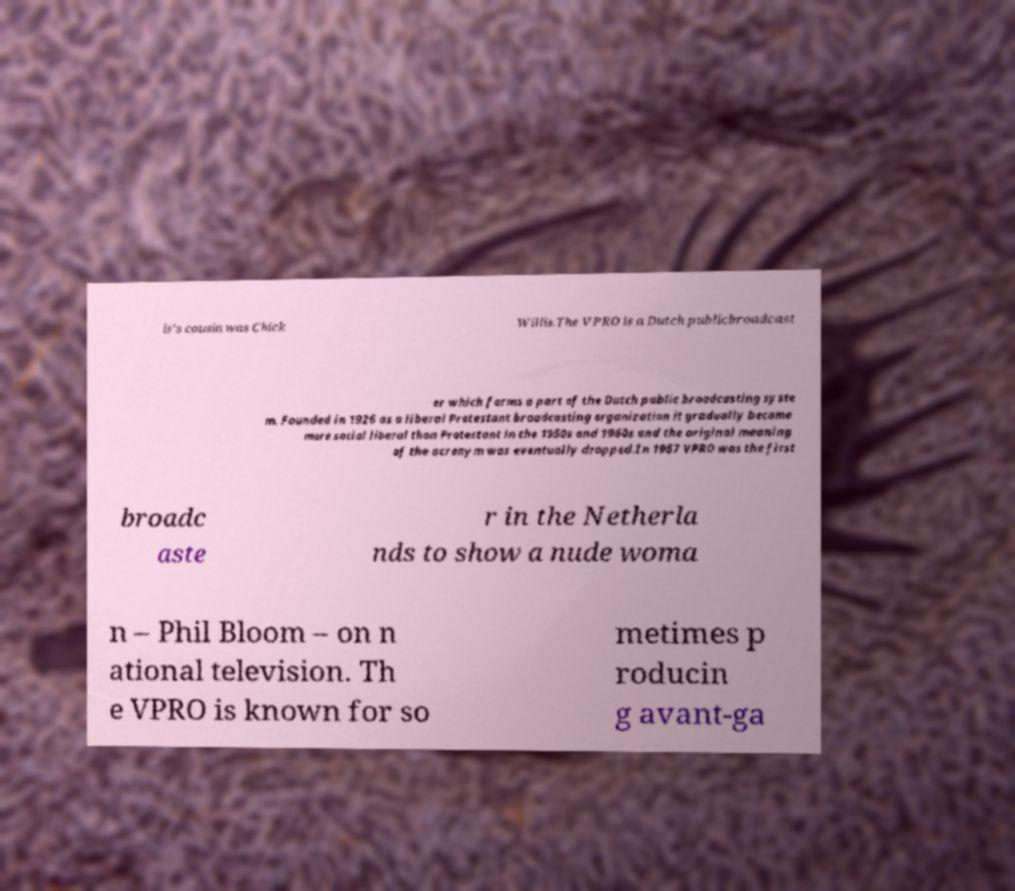Could you assist in decoding the text presented in this image and type it out clearly? is's cousin was Chick Willis.The VPRO is a Dutch publicbroadcast er which forms a part of the Dutch public broadcasting syste m. Founded in 1926 as a liberal Protestant broadcasting organization it gradually became more social liberal than Protestant in the 1950s and 1960s and the original meaning of the acronym was eventually dropped.In 1967 VPRO was the first broadc aste r in the Netherla nds to show a nude woma n – Phil Bloom – on n ational television. Th e VPRO is known for so metimes p roducin g avant-ga 